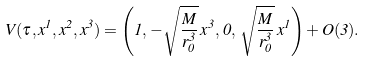<formula> <loc_0><loc_0><loc_500><loc_500>V ( \tau , x ^ { 1 } , x ^ { 2 } , x ^ { 3 } ) = \left ( 1 , \, - \sqrt { \frac { M } { r _ { 0 } ^ { 3 } } } \, x ^ { 3 } , \, 0 , \, \sqrt { \frac { M } { r _ { 0 } ^ { 3 } } } \, x ^ { 1 } \right ) + O ( 3 ) .</formula> 